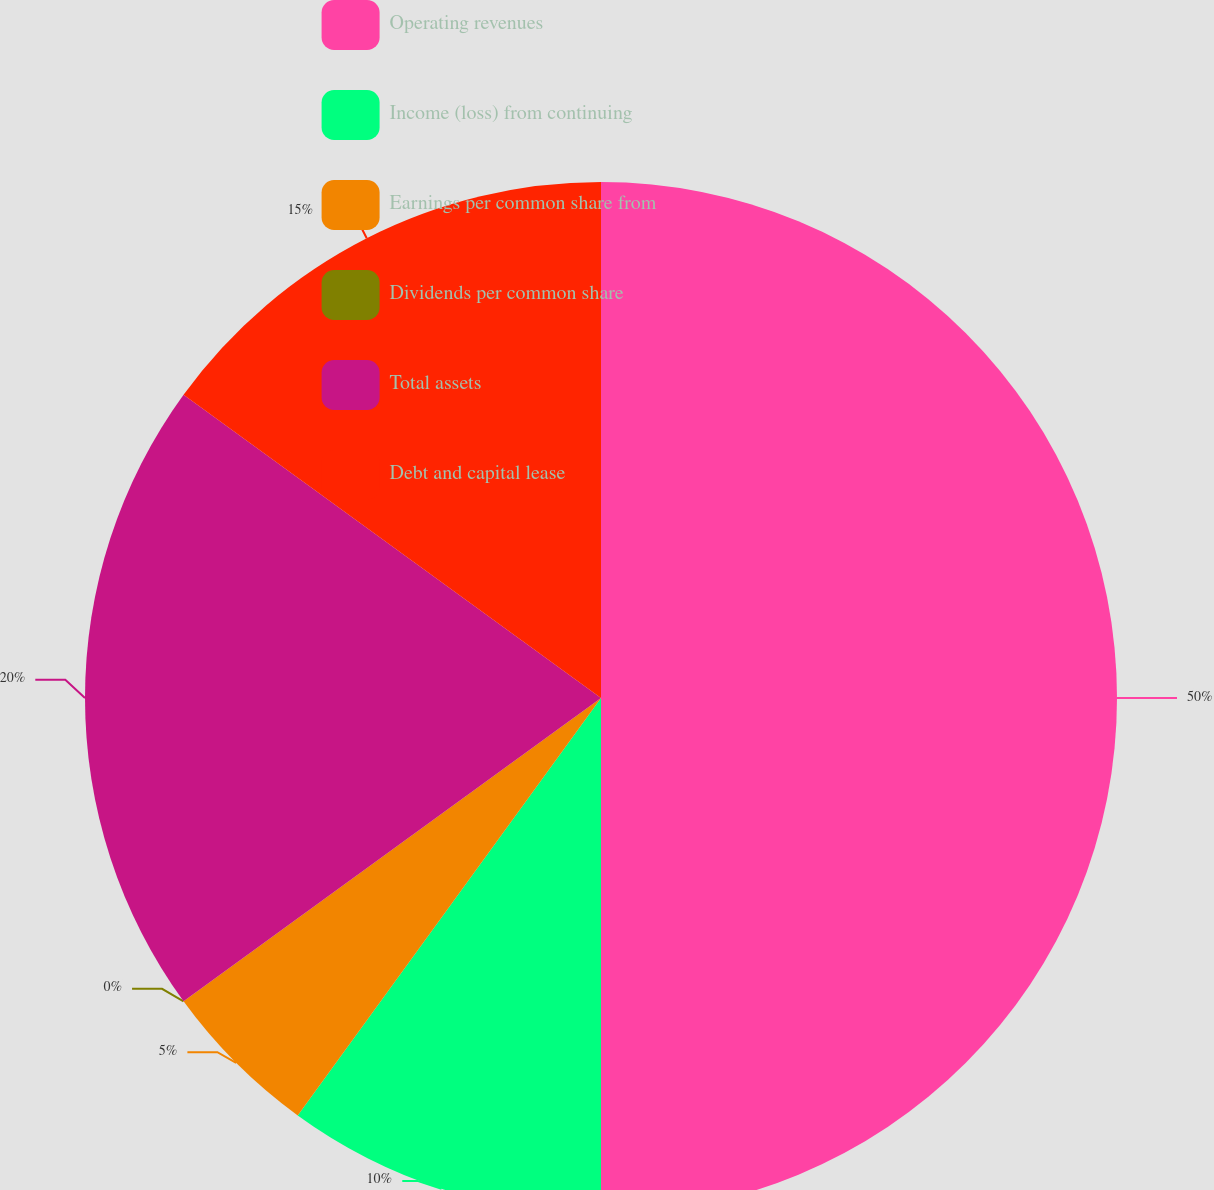<chart> <loc_0><loc_0><loc_500><loc_500><pie_chart><fcel>Operating revenues<fcel>Income (loss) from continuing<fcel>Earnings per common share from<fcel>Dividends per common share<fcel>Total assets<fcel>Debt and capital lease<nl><fcel>50.0%<fcel>10.0%<fcel>5.0%<fcel>0.0%<fcel>20.0%<fcel>15.0%<nl></chart> 